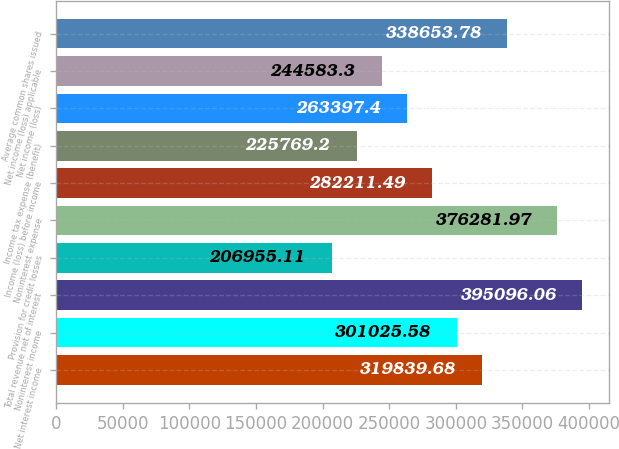<chart> <loc_0><loc_0><loc_500><loc_500><bar_chart><fcel>Net interest income<fcel>Noninterest income<fcel>Total revenue net of interest<fcel>Provision for credit losses<fcel>Noninterest expense<fcel>Income (loss) before income<fcel>Income tax expense (benefit)<fcel>Net income (loss)<fcel>Net income (loss) applicable<fcel>Average common shares issued<nl><fcel>319840<fcel>301026<fcel>395096<fcel>206955<fcel>376282<fcel>282211<fcel>225769<fcel>263397<fcel>244583<fcel>338654<nl></chart> 